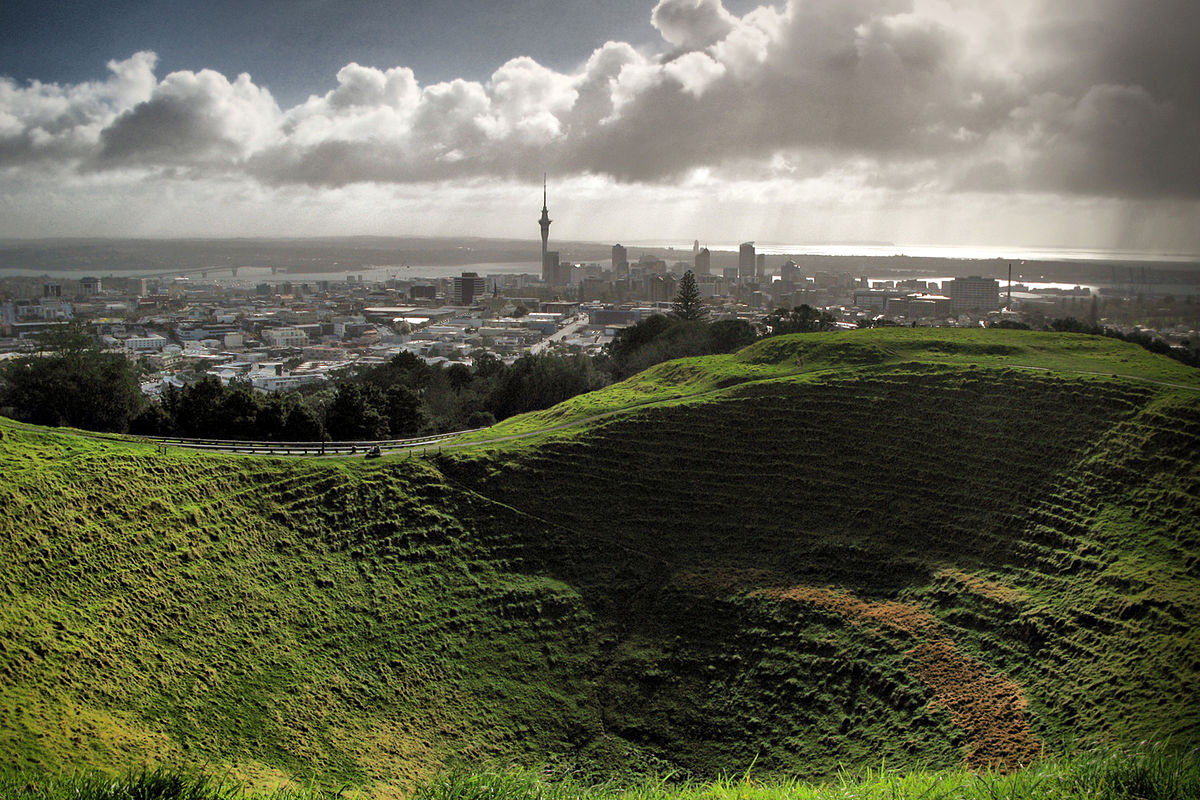Can you describe the main features of this image for me?
 The image captures the stunning view of the Mt Eden Crater in Auckland, New Zealand. From a high vantage point atop the crater, the viewer's gaze is drawn downwards towards the cityscape in the distance. The crater itself is a vibrant expanse of green grass, contrasting with the urban architecture beyond. The sky overhead is a canvas of clouds, with the sun piercing through to cast a warm glow over the scene. The perspective of the photo offers a unique bird's eye view of both the natural landmark and the city it overlooks. 